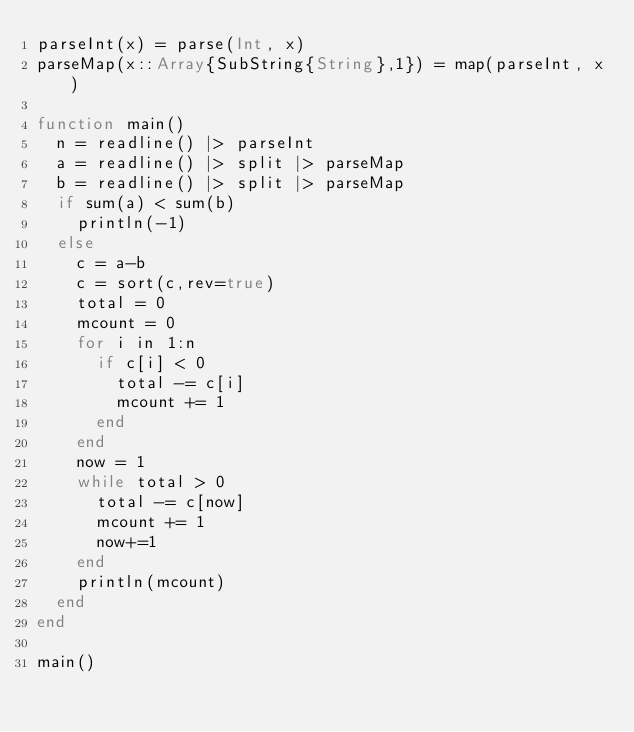Convert code to text. <code><loc_0><loc_0><loc_500><loc_500><_Julia_>parseInt(x) = parse(Int, x)
parseMap(x::Array{SubString{String},1}) = map(parseInt, x)

function main()
	n = readline() |> parseInt
	a = readline() |> split |> parseMap
	b = readline() |> split |> parseMap
	if sum(a) < sum(b)
		println(-1)
	else
		c = a-b
		c = sort(c,rev=true)
		total = 0
		mcount = 0
		for i in 1:n
			if c[i] < 0
				total -= c[i]
				mcount += 1
			end
		end
		now = 1
		while total > 0
			total -= c[now]
			mcount += 1
			now+=1
		end
		println(mcount)
	end
end

main()
</code> 